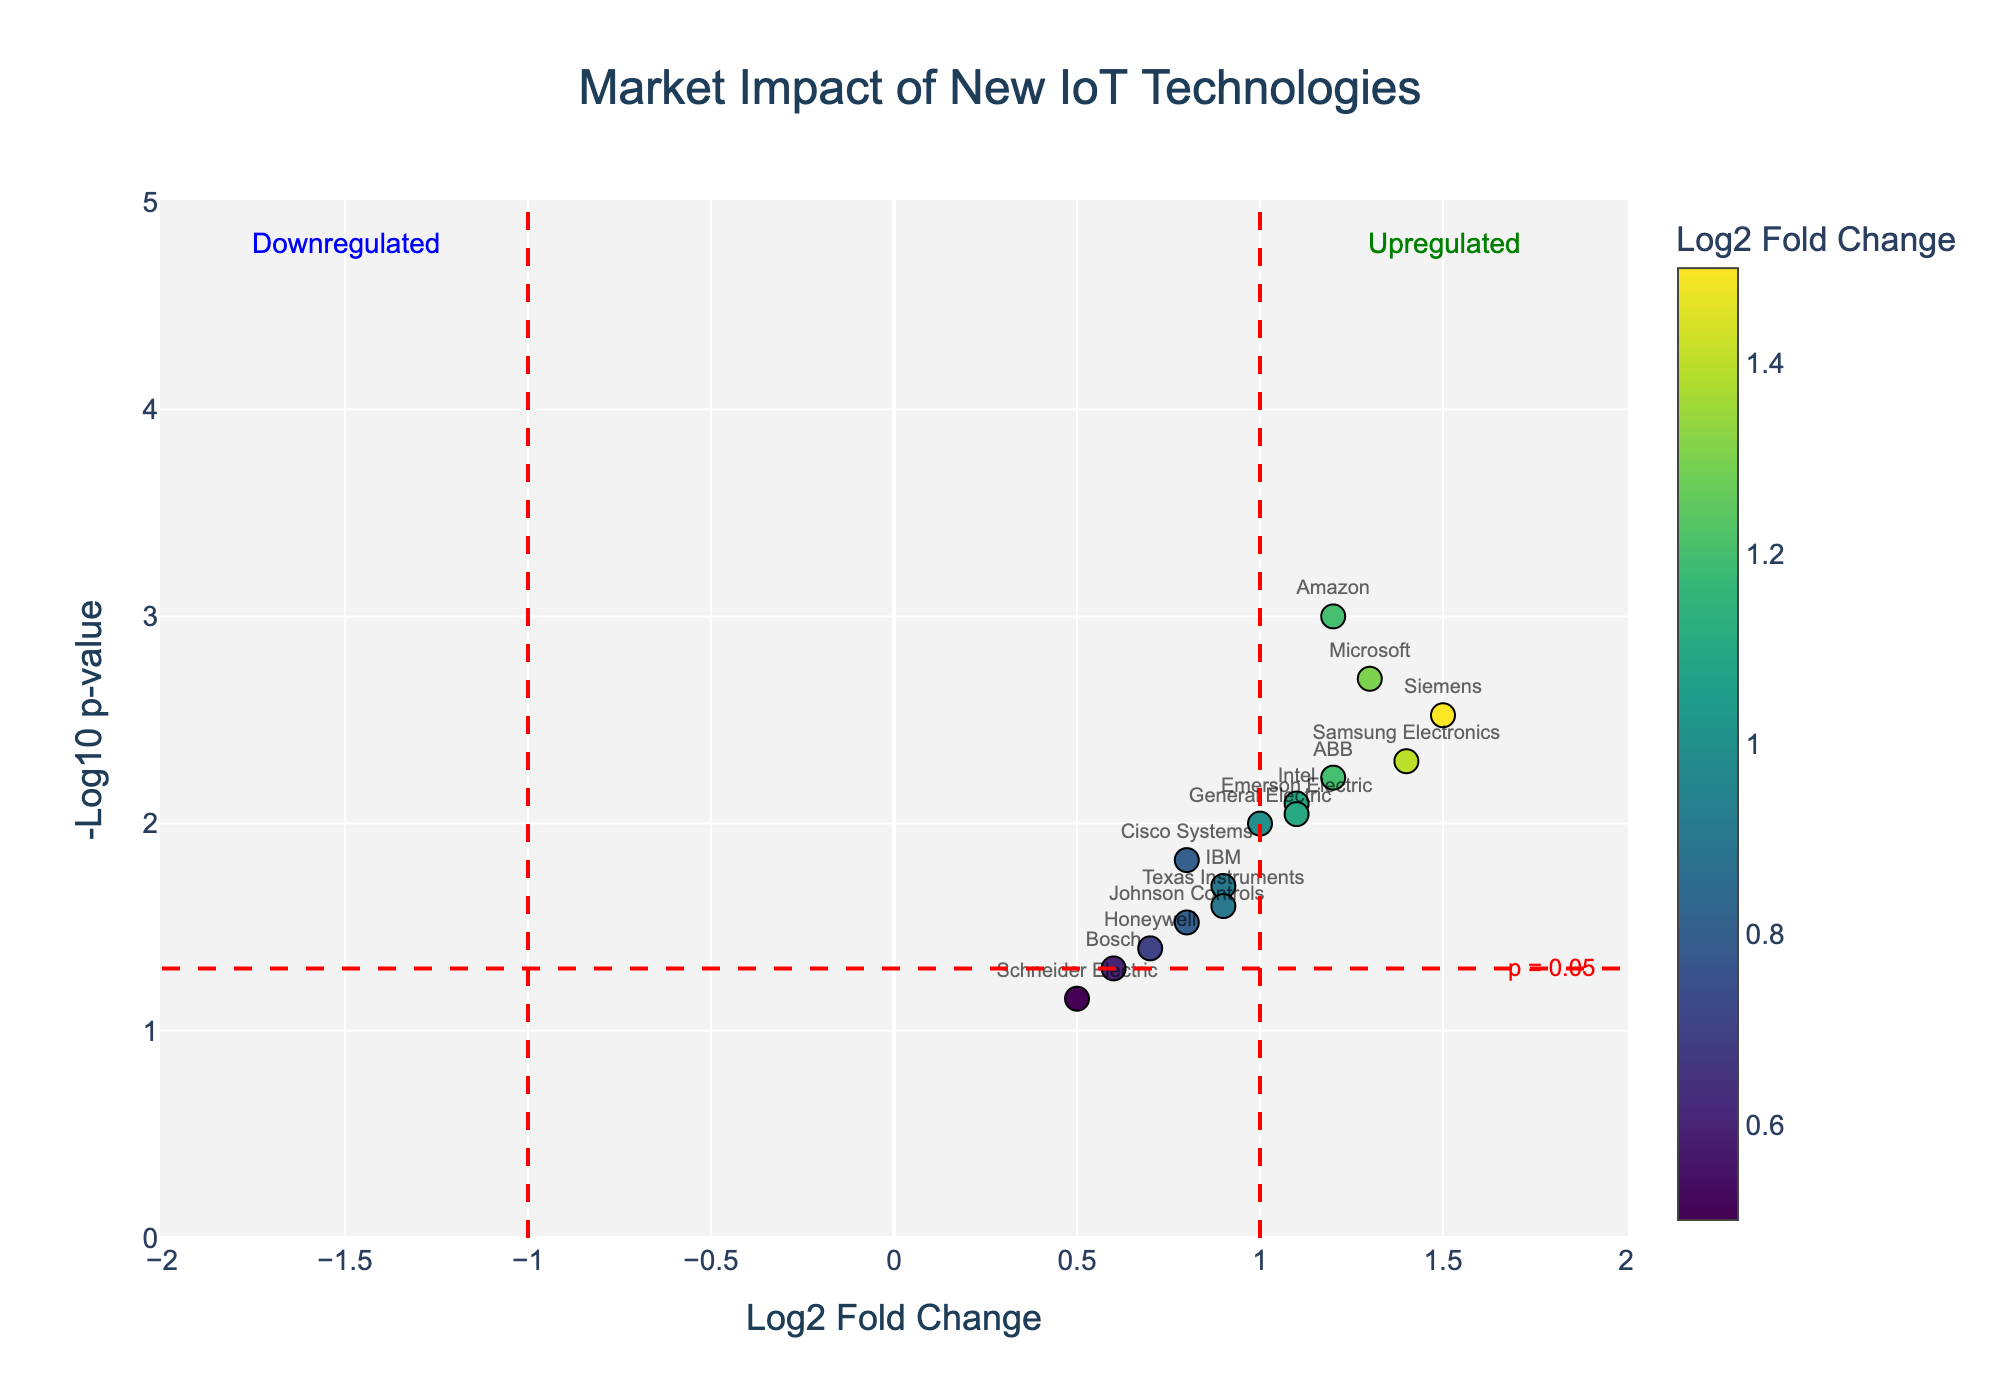What's the title of the figure? The title of the figure is typically displayed at the top and provides an overview of what the figure represents.
Answer: Market Impact of New IoT Technologies How many companies are plotted in the figure? By counting the number of labeled points in the plot, we can determine the number of companies.
Answer: 15 Which company has the highest log2 fold change? To find the company with the highest log2 fold change, look at the x-axis and identify the data point furthest to the right.
Answer: Siemens Which company has the lowest p-value? To determine the company with the lowest p-value, look at the y-axis and identify the point closest to the top of the plot.
Answer: Amazon How many companies have a log2 fold change greater than 1? By visually scanning the plot, count the number of data points located to the right of x = 1 on the x-axis for log2 fold change.
Answer: 8 What is the interpretation of the annotation labeled "Upregulated"? The "Upregulated" label primarily marks the region where the log2 fold change is positive and above the significance threshold line. This signifies that in this area, the stock prices of companies are significantly increased.
Answer: Increased stock prices Which company has a log2 fold change of approximately 1.2 and a p-value less than 0.01? By locating the x value close to 1.2 and the corresponding high y value indicative of a low p-value, we identify the company.
Answer: ABB What trend or pattern do you observe regarding the relationship between log2 fold change and p-value? Generally examining the plot, it appears that higher log2 fold changes tend to correspond to lower p-values, indicating significant market impacts.
Answer: Higher log2 fold changes often have lower p-values What can you infer about Microsoft in this plot? Microsoft has a prominent position in the plot, suggesting it experienced a significant positive impact on its stock price with a high log2 fold change and a low p-value.
Answer: Significant stock price increase Which company is closest to the threshold of significance but is not quite significant? By identifying the data point nearest to but below the p-value threshold line of -log10(p-value) = 1.3 and log2 fold changes near ±1, the closest company not reaching significance is identified.
Answer: Bosch 